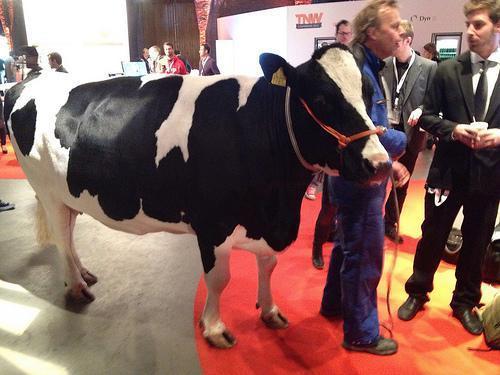How many cows in picture?
Give a very brief answer. 1. How many cow legs are shown?
Give a very brief answer. 4. 